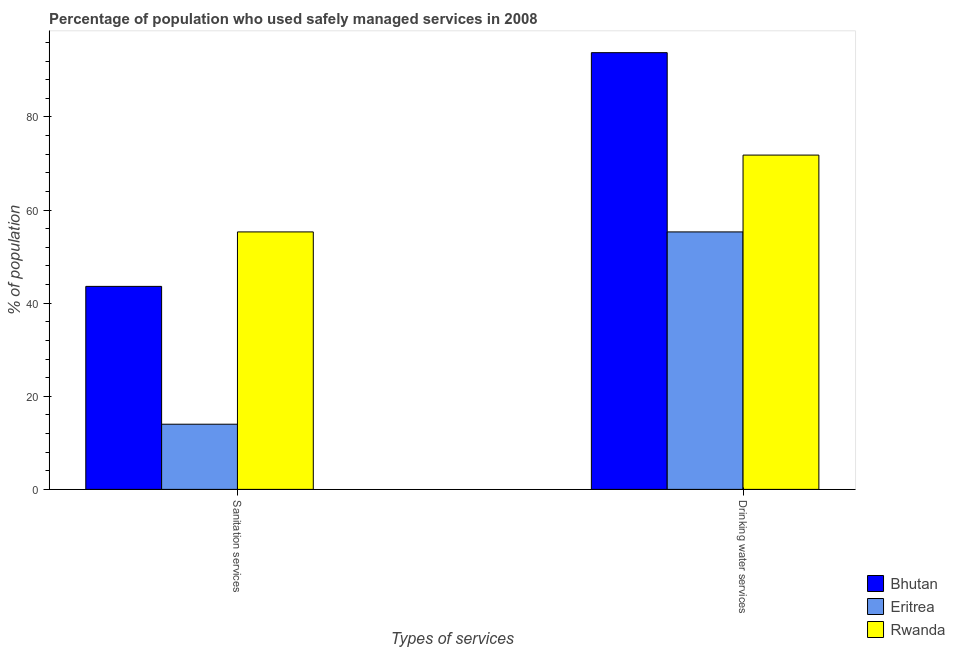How many different coloured bars are there?
Your response must be concise. 3. How many bars are there on the 1st tick from the right?
Provide a short and direct response. 3. What is the label of the 1st group of bars from the left?
Provide a short and direct response. Sanitation services. What is the percentage of population who used drinking water services in Eritrea?
Give a very brief answer. 55.3. Across all countries, what is the maximum percentage of population who used drinking water services?
Keep it short and to the point. 93.8. Across all countries, what is the minimum percentage of population who used drinking water services?
Your answer should be compact. 55.3. In which country was the percentage of population who used sanitation services maximum?
Your answer should be compact. Rwanda. In which country was the percentage of population who used sanitation services minimum?
Your answer should be very brief. Eritrea. What is the total percentage of population who used sanitation services in the graph?
Give a very brief answer. 112.9. What is the difference between the percentage of population who used drinking water services in Bhutan and the percentage of population who used sanitation services in Rwanda?
Ensure brevity in your answer.  38.5. What is the average percentage of population who used drinking water services per country?
Offer a very short reply. 73.63. What is the difference between the percentage of population who used sanitation services and percentage of population who used drinking water services in Bhutan?
Your answer should be very brief. -50.2. What is the ratio of the percentage of population who used drinking water services in Bhutan to that in Eritrea?
Offer a very short reply. 1.7. What does the 2nd bar from the left in Drinking water services represents?
Your answer should be very brief. Eritrea. What does the 1st bar from the right in Sanitation services represents?
Ensure brevity in your answer.  Rwanda. How many countries are there in the graph?
Give a very brief answer. 3. What is the difference between two consecutive major ticks on the Y-axis?
Make the answer very short. 20. Are the values on the major ticks of Y-axis written in scientific E-notation?
Keep it short and to the point. No. Does the graph contain any zero values?
Make the answer very short. No. Where does the legend appear in the graph?
Your answer should be very brief. Bottom right. How many legend labels are there?
Your response must be concise. 3. How are the legend labels stacked?
Your answer should be very brief. Vertical. What is the title of the graph?
Keep it short and to the point. Percentage of population who used safely managed services in 2008. Does "Portugal" appear as one of the legend labels in the graph?
Give a very brief answer. No. What is the label or title of the X-axis?
Provide a succinct answer. Types of services. What is the label or title of the Y-axis?
Provide a short and direct response. % of population. What is the % of population of Bhutan in Sanitation services?
Keep it short and to the point. 43.6. What is the % of population in Eritrea in Sanitation services?
Your answer should be compact. 14. What is the % of population of Rwanda in Sanitation services?
Offer a terse response. 55.3. What is the % of population in Bhutan in Drinking water services?
Provide a succinct answer. 93.8. What is the % of population of Eritrea in Drinking water services?
Make the answer very short. 55.3. What is the % of population of Rwanda in Drinking water services?
Offer a terse response. 71.8. Across all Types of services, what is the maximum % of population in Bhutan?
Give a very brief answer. 93.8. Across all Types of services, what is the maximum % of population of Eritrea?
Give a very brief answer. 55.3. Across all Types of services, what is the maximum % of population of Rwanda?
Provide a succinct answer. 71.8. Across all Types of services, what is the minimum % of population in Bhutan?
Your answer should be very brief. 43.6. Across all Types of services, what is the minimum % of population in Eritrea?
Make the answer very short. 14. Across all Types of services, what is the minimum % of population in Rwanda?
Provide a succinct answer. 55.3. What is the total % of population in Bhutan in the graph?
Your response must be concise. 137.4. What is the total % of population of Eritrea in the graph?
Ensure brevity in your answer.  69.3. What is the total % of population in Rwanda in the graph?
Offer a terse response. 127.1. What is the difference between the % of population in Bhutan in Sanitation services and that in Drinking water services?
Ensure brevity in your answer.  -50.2. What is the difference between the % of population of Eritrea in Sanitation services and that in Drinking water services?
Your answer should be very brief. -41.3. What is the difference between the % of population of Rwanda in Sanitation services and that in Drinking water services?
Your answer should be compact. -16.5. What is the difference between the % of population of Bhutan in Sanitation services and the % of population of Eritrea in Drinking water services?
Offer a very short reply. -11.7. What is the difference between the % of population of Bhutan in Sanitation services and the % of population of Rwanda in Drinking water services?
Make the answer very short. -28.2. What is the difference between the % of population in Eritrea in Sanitation services and the % of population in Rwanda in Drinking water services?
Offer a terse response. -57.8. What is the average % of population of Bhutan per Types of services?
Your answer should be very brief. 68.7. What is the average % of population in Eritrea per Types of services?
Provide a succinct answer. 34.65. What is the average % of population of Rwanda per Types of services?
Provide a succinct answer. 63.55. What is the difference between the % of population of Bhutan and % of population of Eritrea in Sanitation services?
Keep it short and to the point. 29.6. What is the difference between the % of population of Eritrea and % of population of Rwanda in Sanitation services?
Ensure brevity in your answer.  -41.3. What is the difference between the % of population in Bhutan and % of population in Eritrea in Drinking water services?
Your answer should be compact. 38.5. What is the difference between the % of population of Bhutan and % of population of Rwanda in Drinking water services?
Keep it short and to the point. 22. What is the difference between the % of population in Eritrea and % of population in Rwanda in Drinking water services?
Offer a terse response. -16.5. What is the ratio of the % of population of Bhutan in Sanitation services to that in Drinking water services?
Your response must be concise. 0.46. What is the ratio of the % of population in Eritrea in Sanitation services to that in Drinking water services?
Offer a terse response. 0.25. What is the ratio of the % of population of Rwanda in Sanitation services to that in Drinking water services?
Make the answer very short. 0.77. What is the difference between the highest and the second highest % of population of Bhutan?
Make the answer very short. 50.2. What is the difference between the highest and the second highest % of population in Eritrea?
Offer a very short reply. 41.3. What is the difference between the highest and the lowest % of population in Bhutan?
Give a very brief answer. 50.2. What is the difference between the highest and the lowest % of population of Eritrea?
Your response must be concise. 41.3. What is the difference between the highest and the lowest % of population in Rwanda?
Your answer should be compact. 16.5. 